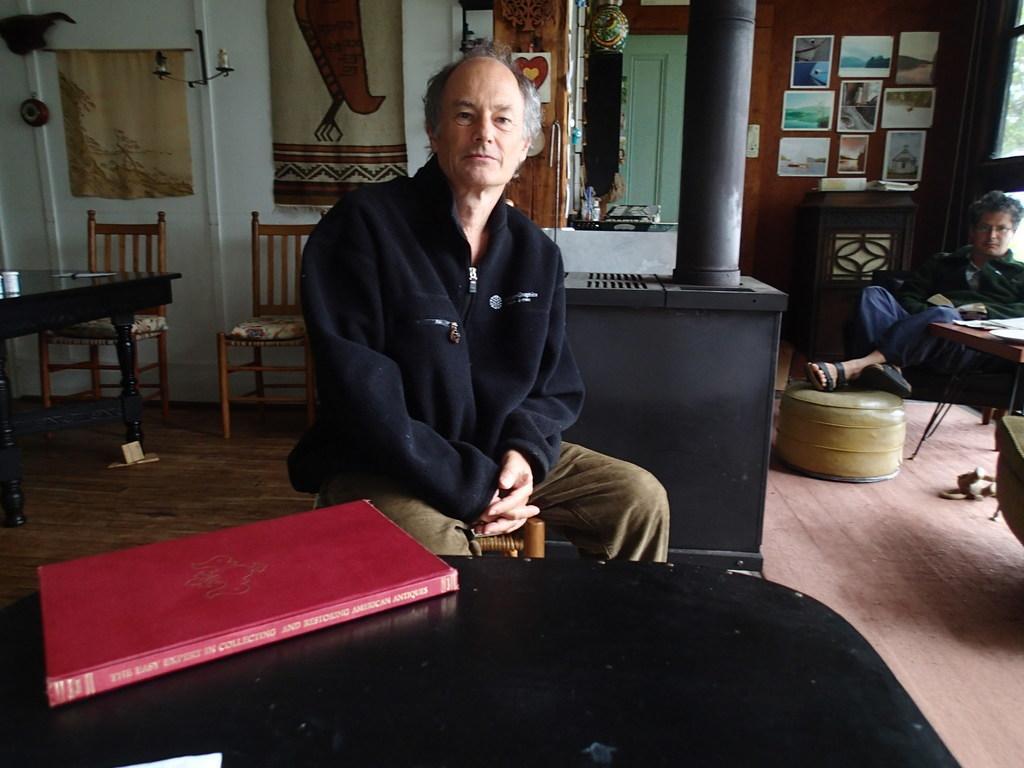Please provide a concise description of this image. In this image, a old human was sat on the wooden chair. Right side, another human is there. We can see few photo frames are there at the wall. There is a white color door , ash color pillar on the right side. The left side, we can see a black color table ,2 chairs, some wall hangings and candle. In bottom there is an another table. A book is placed on it. we can see right few items are placed on the table. 